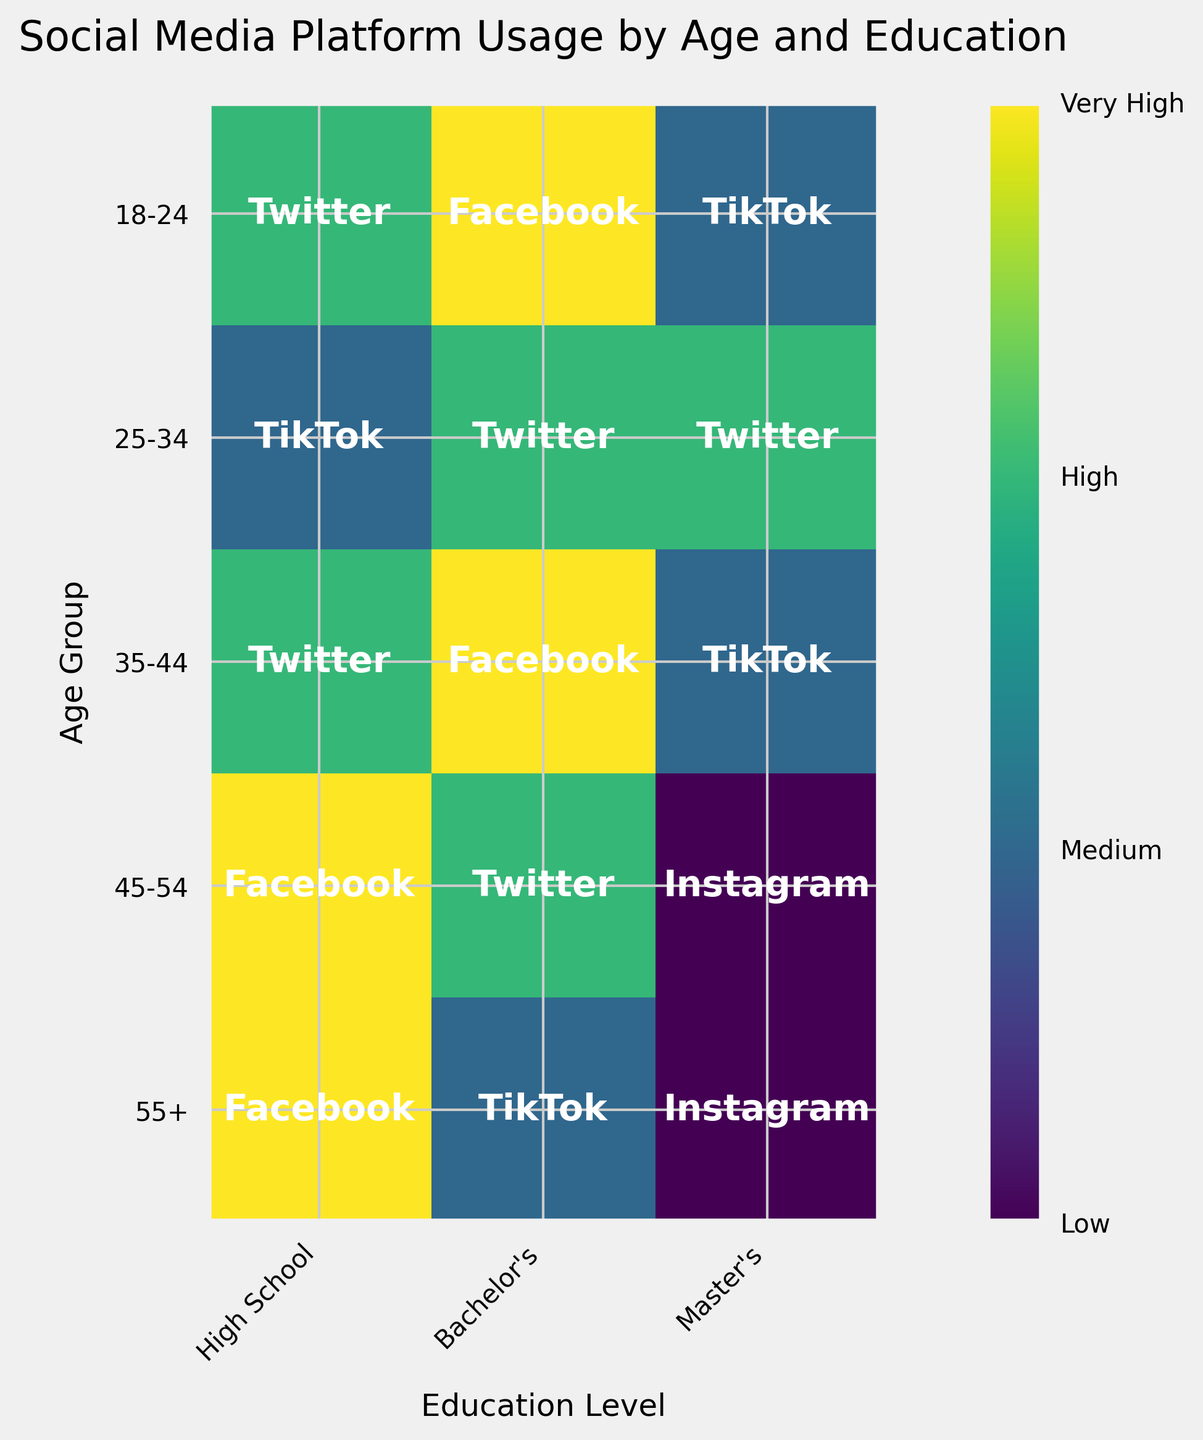What is the most frequently used platform for the age group 18-24 with a bachelor's degree? In the chart, look at the row for the age group 18-24 and the column for Bachelor's education level. The color and annotation indicate the most frequently used platform.
Answer: TikTok Which age group shows the highest usage of Facebook? Identify the darkest or most intense color labeled with Facebook across all age groups.
Answer: 45-54 How does the frequency of LinkedIn usage compare between the age groups 25-34 and 55+ with a bachelor's degree? Look at the rows for the age groups 25-34 and 55+ in the column for Bachelor's education level. Compare the colors and annotations for LinkedIn. The intensity shows higher usage for the former.
Answer: 25-34 Which social media platform is least frequently used by individuals aged 45-54 with a master's degree? Locate the cell for age group 45-54 and master's degree and identify the platform with the lightest color representing the lowest frequency.
Answer: Twitter What is the title of the figure? Read the title from the top of the figure.
Answer: Social Media Platform Usage by Age and Education Which education level has the highest usage frequency of Instagram by individuals aged 18-24? Find the row 18-24 and check the usage frequency at each education level. The highest is represented by the darkest color or the top annotation.
Answer: High School How is the frequency of Twitter usage for the age groups 35-44 and 55+ with a master's degree different? Compare the colors for Twitter in the master's degree cells for the age groups 35-44 and 55+. The color shades will show the difference in usage.
Answer: 35-44 has Medium and 55+ has Low Which platform is used at a 'High' frequency by individuals aged 35-44 with a high school diploma? Look at the cell for age group 35-44 and High School. Identify the platform associated with the color corresponding to 'High'.
Answer: Facebook Is the frequency of platform usage higher for 18-24-year-olds or for 45-54-year-olds with a high school education? Compare the color intensities in the High School column for both age groups 18-24 and 45-54. Higher frequency corresponds with darker shades.
Answer: 45-54 What is the color that represents a 'Very High' frequency in the chart? Check the legend or color bar indicating different frequency levels and identify the color for 'Very High'.
Answer: Darkest shade in the color bar 